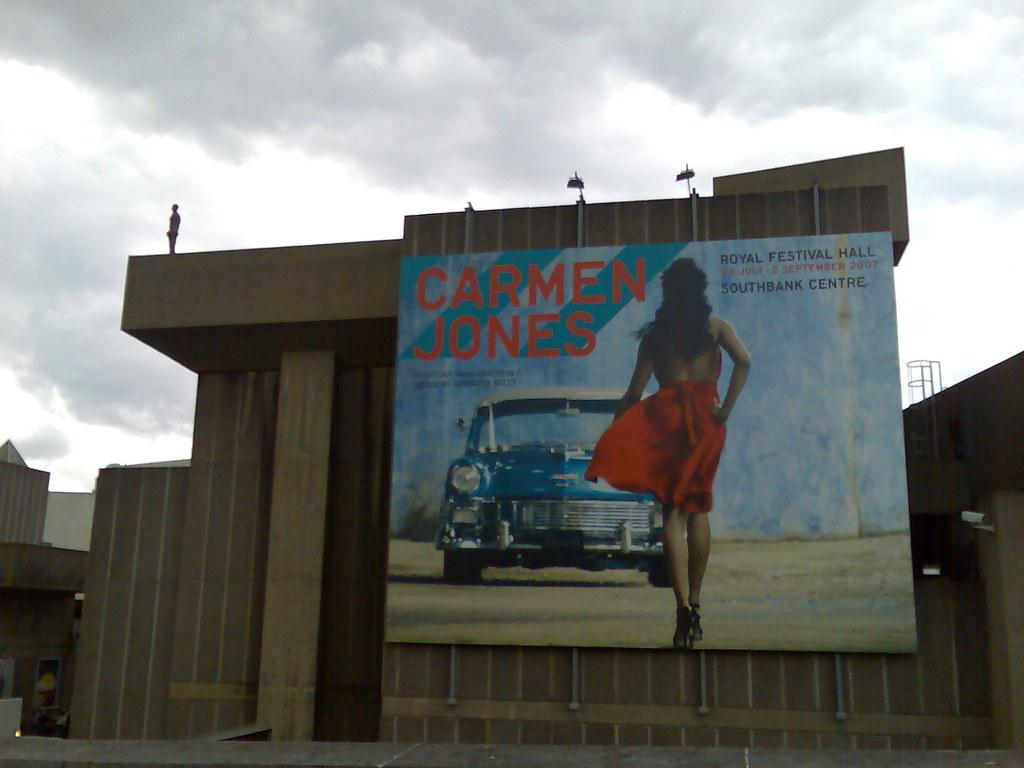Provide a one-sentence caption for the provided image. The poster on the wall has a photo of a car and is advertising a film starring Carmen Jones. 